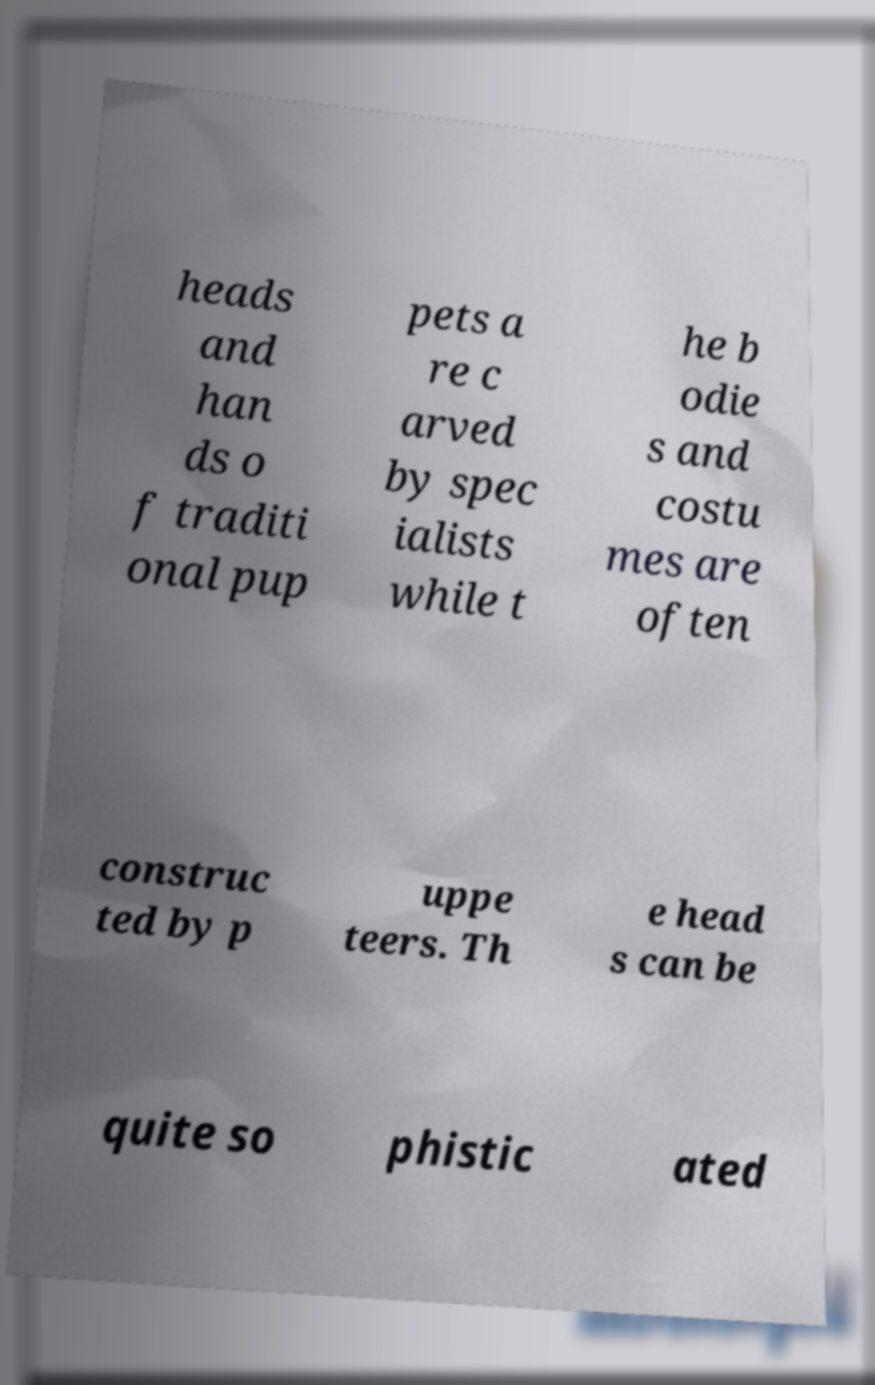Can you read and provide the text displayed in the image?This photo seems to have some interesting text. Can you extract and type it out for me? heads and han ds o f traditi onal pup pets a re c arved by spec ialists while t he b odie s and costu mes are often construc ted by p uppe teers. Th e head s can be quite so phistic ated 